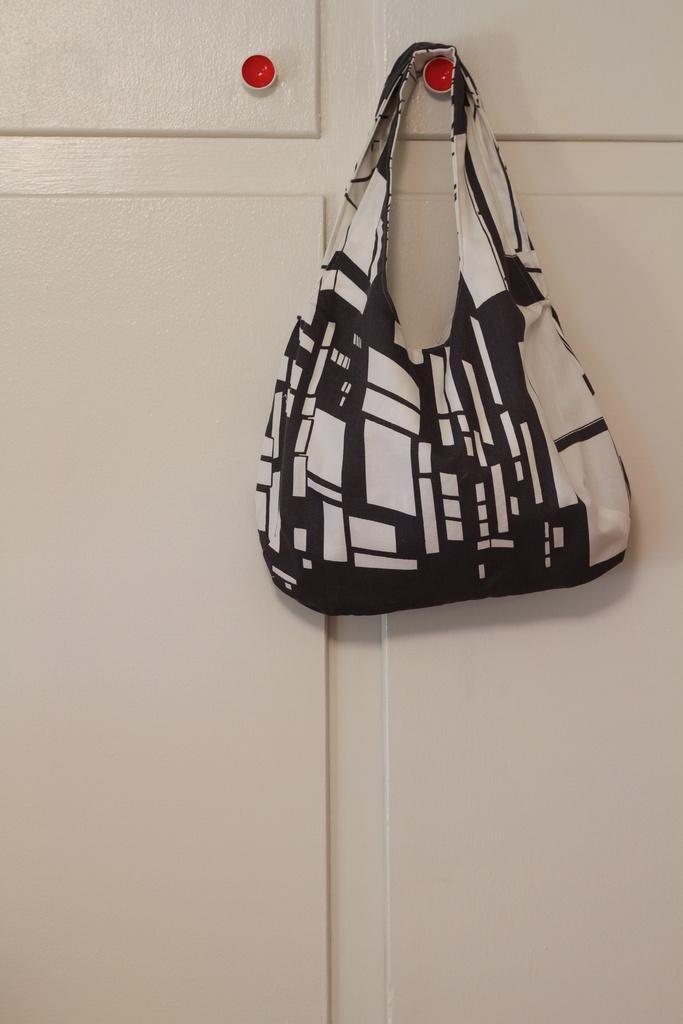How would you summarize this image in a sentence or two? This picture shows a woman's handbag. 